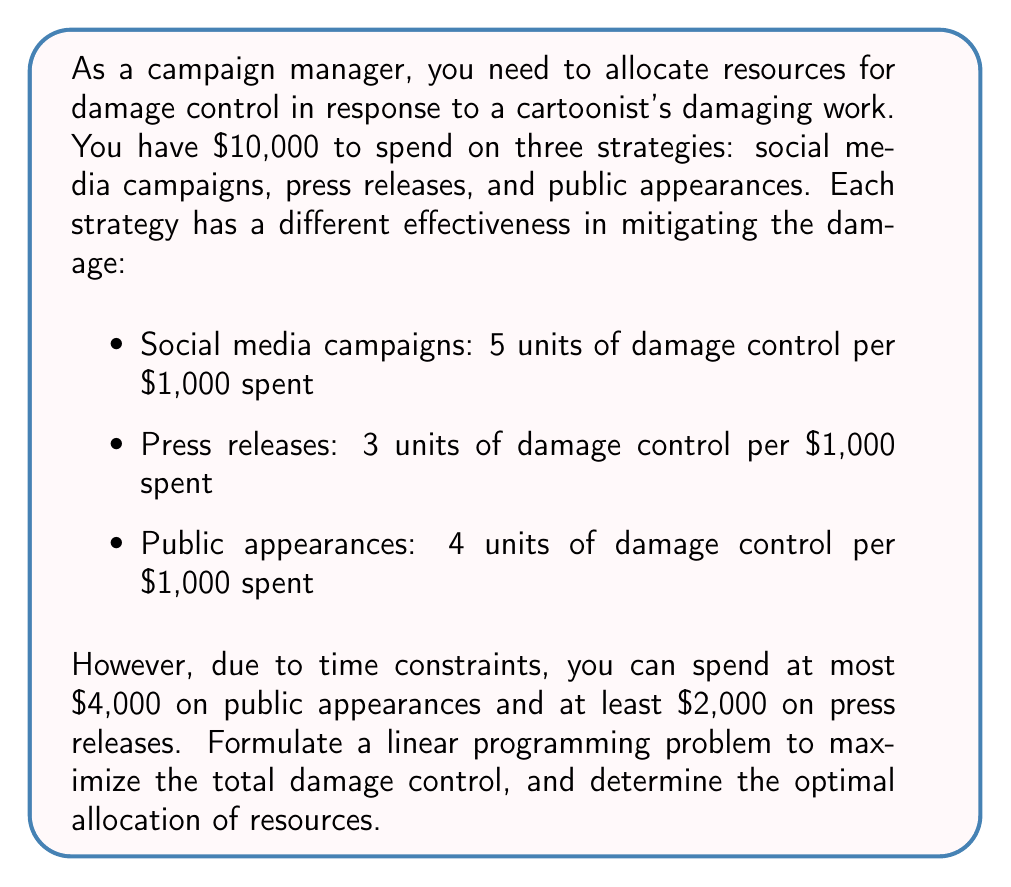Provide a solution to this math problem. Let's approach this problem step by step using linear programming:

1. Define variables:
   Let $x$ = amount spent on social media campaigns (in thousands)
   Let $y$ = amount spent on press releases (in thousands)
   Let $z$ = amount spent on public appearances (in thousands)

2. Objective function:
   Maximize total damage control: $5x + 3y + 4z$

3. Constraints:
   a) Total budget: $x + y + z \leq 10$
   b) Minimum spend on press releases: $y \geq 2$
   c) Maximum spend on public appearances: $z \leq 4$
   d) Non-negativity: $x, y, z \geq 0$

4. The linear programming problem:

   Maximize: $5x + 3y + 4z$
   Subject to:
   $$\begin{align}
   x + y + z &\leq 10 \\
   y &\geq 2 \\
   z &\leq 4 \\
   x, y, z &\geq 0
   \end{align}$$

5. To solve this, we can use the graphical method or simplex algorithm. In this case, we'll use the corner point method:

   Possible corner points:
   (0, 2, 4), (0, 6, 4), (4, 2, 4), (6, 2, 2), (8, 2, 0)

6. Evaluate the objective function at each point:
   (0, 2, 4): $5(0) + 3(2) + 4(4) = 22$
   (0, 6, 4): $5(0) + 3(6) + 4(4) = 34$
   (4, 2, 4): $5(4) + 3(2) + 4(4) = 38$
   (6, 2, 2): $5(6) + 3(2) + 4(2) = 40$
   (8, 2, 0): $5(8) + 3(2) + 4(0) = 46$

The maximum value of the objective function is 46, achieved at the point (8, 2, 0).
Answer: The optimal allocation of resources is:
$8,000 on social media campaigns
$2,000 on press releases
$0 on public appearances
This allocation yields a maximum damage control of 46 units. 